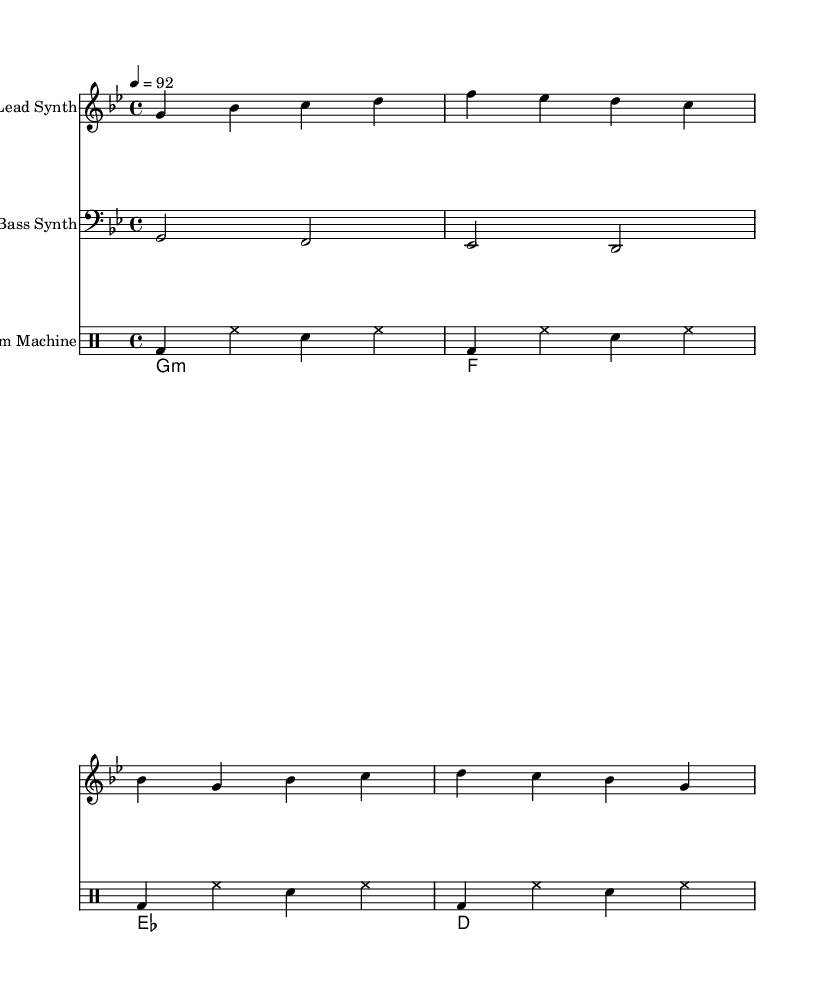What is the key signature of this music? The key signature is indicated by the key signature symbol at the beginning of the staff, which has one flat. This corresponds to G minor.
Answer: G minor What is the time signature used in this music? The time signature is found at the beginning of the staff and is represented as a fraction. It shows 4 beats per measure, which is indicated by the "4/4" notation.
Answer: 4/4 What is the tempo marking for this music? The tempo marking is provided at the beginning of the score, which indicates the speed of the piece, listed as "4 = 92". This means 92 beats per minute.
Answer: 92 What type of instruments are used in this piece? The instruments are specified in the header of each staff. There is a "Lead Synth", "Bass Synth", and "Drum Machine". This information corresponds to the unique instruments contributing to the hip hop feel.
Answer: Lead Synth, Bass Synth, Drum Machine How many measures are in the Lead Synth part? To find the number of measures in the Lead Synth part, count the number of distinct phrases separated by bar lines in the Lead Synth staff. There are four distinct phrases in total.
Answer: 4 What are the primary chords used in this piece? The primary chords can be seen in the Chord Names staff, where the chords are listed in sequence. They are G minor (g1:m), F, E flat (es), and D.
Answer: G minor, F, E flat, D What is the lyrical theme of this hip hop music? The lyrics provided can be analyzed for their content, which emphasizes motivation and the idea of self-made success. The lines promote hard work and a positive mindset, capturing common themes in motivational hip hop.
Answer: Motivation and self-made success 